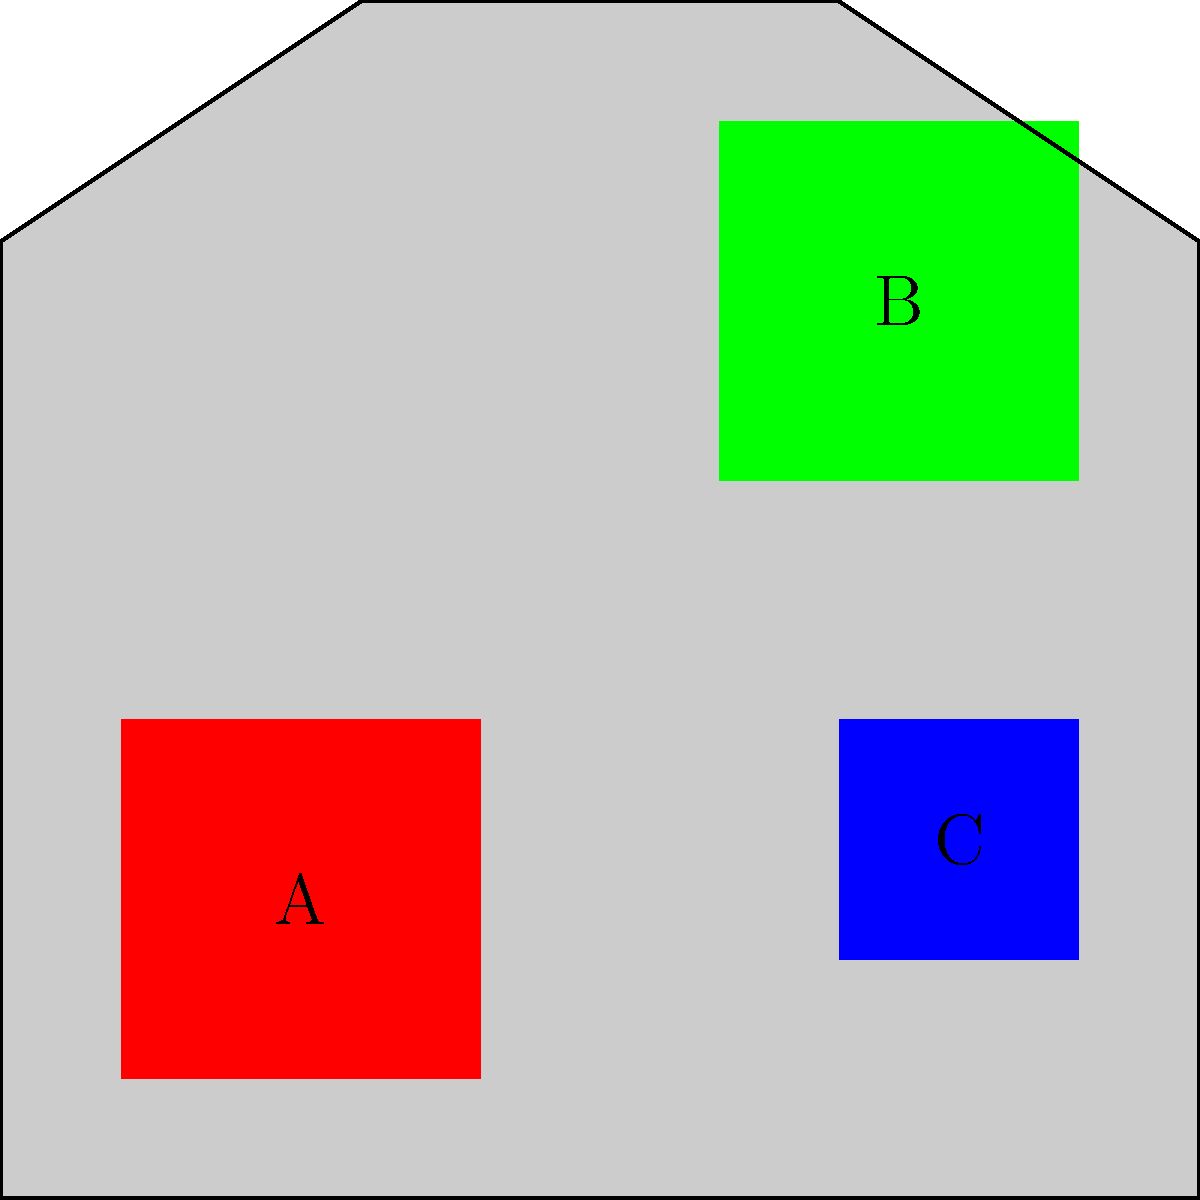The color-coded map of Martha's Vineyard shows three distinct regions (A, B, and C) representing different habitats for endangered species. Red areas indicate coastal dunes, green areas represent inland forests, and blue areas denote freshwater wetlands. Based on this distribution, which habitat type appears to cover the largest area for endangered species on the island? To determine which habitat type covers the largest area for endangered species, we need to analyze the color-coded regions on the map:

1. Red area (Region A): Represents coastal dunes. This area appears to be medium-sized, covering the southwestern part of the island.

2. Green area (Region B): Represents inland forests. This area is located in the northeastern part of the island and appears to be the largest of the three colored regions.

3. Blue area (Region C): Represents freshwater wetlands. This area is the smallest, located in the eastern part of the island.

Comparing the sizes of these regions:
- The green area (B) is visibly larger than both the red (A) and blue (C) areas.
- The red area (A) is smaller than the green area (B) but larger than the blue area (C).
- The blue area (C) is the smallest of the three regions.

Therefore, based on this color-coded map, the inland forests (represented by the green area) appear to cover the largest area for endangered species on Martha's Vineyard.
Answer: Inland forests 